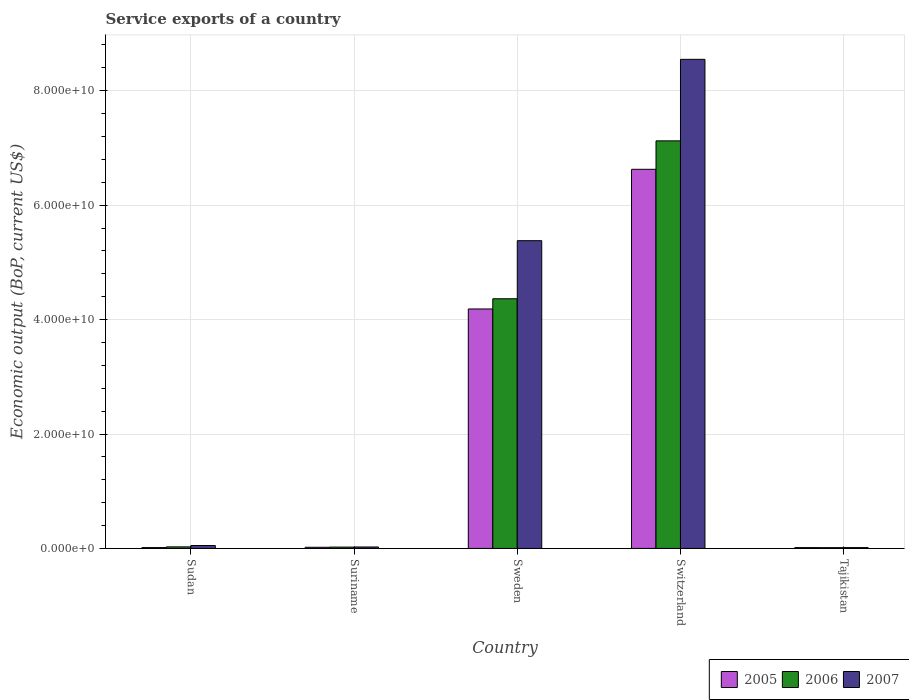How many groups of bars are there?
Offer a terse response. 5. How many bars are there on the 4th tick from the left?
Provide a short and direct response. 3. What is the label of the 2nd group of bars from the left?
Offer a terse response. Suriname. In how many cases, is the number of bars for a given country not equal to the number of legend labels?
Make the answer very short. 0. What is the service exports in 2007 in Switzerland?
Your answer should be compact. 8.55e+1. Across all countries, what is the maximum service exports in 2005?
Your answer should be compact. 6.63e+1. Across all countries, what is the minimum service exports in 2005?
Offer a very short reply. 1.46e+08. In which country was the service exports in 2005 maximum?
Make the answer very short. Switzerland. In which country was the service exports in 2007 minimum?
Ensure brevity in your answer.  Tajikistan. What is the total service exports in 2005 in the graph?
Make the answer very short. 1.09e+11. What is the difference between the service exports in 2007 in Sudan and that in Suriname?
Offer a very short reply. 2.57e+08. What is the difference between the service exports in 2006 in Switzerland and the service exports in 2007 in Tajikistan?
Make the answer very short. 7.11e+1. What is the average service exports in 2005 per country?
Your answer should be compact. 2.17e+1. What is the difference between the service exports of/in 2007 and service exports of/in 2005 in Sudan?
Give a very brief answer. 3.63e+08. In how many countries, is the service exports in 2005 greater than 8000000000 US$?
Your answer should be very brief. 2. What is the ratio of the service exports in 2005 in Suriname to that in Tajikistan?
Ensure brevity in your answer.  1.39. Is the difference between the service exports in 2007 in Sudan and Sweden greater than the difference between the service exports in 2005 in Sudan and Sweden?
Your answer should be compact. No. What is the difference between the highest and the second highest service exports in 2006?
Provide a succinct answer. 7.10e+1. What is the difference between the highest and the lowest service exports in 2005?
Keep it short and to the point. 6.61e+1. Is the sum of the service exports in 2006 in Suriname and Tajikistan greater than the maximum service exports in 2007 across all countries?
Keep it short and to the point. No. What does the 1st bar from the left in Switzerland represents?
Make the answer very short. 2005. What does the 3rd bar from the right in Sweden represents?
Ensure brevity in your answer.  2005. Is it the case that in every country, the sum of the service exports in 2006 and service exports in 2007 is greater than the service exports in 2005?
Give a very brief answer. Yes. Are the values on the major ticks of Y-axis written in scientific E-notation?
Ensure brevity in your answer.  Yes. Does the graph contain any zero values?
Make the answer very short. No. Does the graph contain grids?
Keep it short and to the point. Yes. Where does the legend appear in the graph?
Ensure brevity in your answer.  Bottom right. What is the title of the graph?
Make the answer very short. Service exports of a country. What is the label or title of the X-axis?
Provide a succinct answer. Country. What is the label or title of the Y-axis?
Give a very brief answer. Economic output (BoP, current US$). What is the Economic output (BoP, current US$) of 2005 in Sudan?
Your response must be concise. 1.47e+08. What is the Economic output (BoP, current US$) of 2006 in Sudan?
Offer a terse response. 2.74e+08. What is the Economic output (BoP, current US$) of 2007 in Sudan?
Offer a terse response. 5.10e+08. What is the Economic output (BoP, current US$) of 2005 in Suriname?
Keep it short and to the point. 2.04e+08. What is the Economic output (BoP, current US$) of 2006 in Suriname?
Offer a very short reply. 2.37e+08. What is the Economic output (BoP, current US$) of 2007 in Suriname?
Give a very brief answer. 2.53e+08. What is the Economic output (BoP, current US$) of 2005 in Sweden?
Your answer should be compact. 4.19e+1. What is the Economic output (BoP, current US$) in 2006 in Sweden?
Your answer should be very brief. 4.36e+1. What is the Economic output (BoP, current US$) of 2007 in Sweden?
Your answer should be very brief. 5.38e+1. What is the Economic output (BoP, current US$) of 2005 in Switzerland?
Make the answer very short. 6.63e+1. What is the Economic output (BoP, current US$) of 2006 in Switzerland?
Your answer should be compact. 7.12e+1. What is the Economic output (BoP, current US$) of 2007 in Switzerland?
Make the answer very short. 8.55e+1. What is the Economic output (BoP, current US$) in 2005 in Tajikistan?
Your answer should be very brief. 1.46e+08. What is the Economic output (BoP, current US$) in 2006 in Tajikistan?
Offer a very short reply. 1.34e+08. What is the Economic output (BoP, current US$) of 2007 in Tajikistan?
Your response must be concise. 1.49e+08. Across all countries, what is the maximum Economic output (BoP, current US$) of 2005?
Provide a succinct answer. 6.63e+1. Across all countries, what is the maximum Economic output (BoP, current US$) in 2006?
Give a very brief answer. 7.12e+1. Across all countries, what is the maximum Economic output (BoP, current US$) of 2007?
Your answer should be very brief. 8.55e+1. Across all countries, what is the minimum Economic output (BoP, current US$) of 2005?
Offer a very short reply. 1.46e+08. Across all countries, what is the minimum Economic output (BoP, current US$) in 2006?
Offer a very short reply. 1.34e+08. Across all countries, what is the minimum Economic output (BoP, current US$) in 2007?
Your answer should be compact. 1.49e+08. What is the total Economic output (BoP, current US$) of 2005 in the graph?
Ensure brevity in your answer.  1.09e+11. What is the total Economic output (BoP, current US$) in 2006 in the graph?
Provide a succinct answer. 1.16e+11. What is the total Economic output (BoP, current US$) in 2007 in the graph?
Your answer should be compact. 1.40e+11. What is the difference between the Economic output (BoP, current US$) in 2005 in Sudan and that in Suriname?
Your answer should be very brief. -5.71e+07. What is the difference between the Economic output (BoP, current US$) of 2006 in Sudan and that in Suriname?
Your answer should be compact. 3.73e+07. What is the difference between the Economic output (BoP, current US$) of 2007 in Sudan and that in Suriname?
Your response must be concise. 2.57e+08. What is the difference between the Economic output (BoP, current US$) of 2005 in Sudan and that in Sweden?
Offer a very short reply. -4.17e+1. What is the difference between the Economic output (BoP, current US$) in 2006 in Sudan and that in Sweden?
Your answer should be very brief. -4.34e+1. What is the difference between the Economic output (BoP, current US$) in 2007 in Sudan and that in Sweden?
Your answer should be very brief. -5.33e+1. What is the difference between the Economic output (BoP, current US$) of 2005 in Sudan and that in Switzerland?
Your answer should be compact. -6.61e+1. What is the difference between the Economic output (BoP, current US$) of 2006 in Sudan and that in Switzerland?
Make the answer very short. -7.10e+1. What is the difference between the Economic output (BoP, current US$) in 2007 in Sudan and that in Switzerland?
Provide a succinct answer. -8.50e+1. What is the difference between the Economic output (BoP, current US$) in 2005 in Sudan and that in Tajikistan?
Provide a succinct answer. 6.82e+05. What is the difference between the Economic output (BoP, current US$) of 2006 in Sudan and that in Tajikistan?
Keep it short and to the point. 1.40e+08. What is the difference between the Economic output (BoP, current US$) of 2007 in Sudan and that in Tajikistan?
Your answer should be very brief. 3.62e+08. What is the difference between the Economic output (BoP, current US$) of 2005 in Suriname and that in Sweden?
Your answer should be compact. -4.17e+1. What is the difference between the Economic output (BoP, current US$) of 2006 in Suriname and that in Sweden?
Your answer should be compact. -4.34e+1. What is the difference between the Economic output (BoP, current US$) in 2007 in Suriname and that in Sweden?
Offer a very short reply. -5.35e+1. What is the difference between the Economic output (BoP, current US$) in 2005 in Suriname and that in Switzerland?
Give a very brief answer. -6.61e+1. What is the difference between the Economic output (BoP, current US$) in 2006 in Suriname and that in Switzerland?
Offer a terse response. -7.10e+1. What is the difference between the Economic output (BoP, current US$) of 2007 in Suriname and that in Switzerland?
Ensure brevity in your answer.  -8.52e+1. What is the difference between the Economic output (BoP, current US$) of 2005 in Suriname and that in Tajikistan?
Provide a succinct answer. 5.78e+07. What is the difference between the Economic output (BoP, current US$) in 2006 in Suriname and that in Tajikistan?
Make the answer very short. 1.02e+08. What is the difference between the Economic output (BoP, current US$) of 2007 in Suriname and that in Tajikistan?
Ensure brevity in your answer.  1.05e+08. What is the difference between the Economic output (BoP, current US$) of 2005 in Sweden and that in Switzerland?
Offer a very short reply. -2.44e+1. What is the difference between the Economic output (BoP, current US$) in 2006 in Sweden and that in Switzerland?
Your answer should be very brief. -2.76e+1. What is the difference between the Economic output (BoP, current US$) of 2007 in Sweden and that in Switzerland?
Your response must be concise. -3.17e+1. What is the difference between the Economic output (BoP, current US$) in 2005 in Sweden and that in Tajikistan?
Offer a terse response. 4.17e+1. What is the difference between the Economic output (BoP, current US$) of 2006 in Sweden and that in Tajikistan?
Your answer should be compact. 4.35e+1. What is the difference between the Economic output (BoP, current US$) of 2007 in Sweden and that in Tajikistan?
Make the answer very short. 5.36e+1. What is the difference between the Economic output (BoP, current US$) in 2005 in Switzerland and that in Tajikistan?
Provide a succinct answer. 6.61e+1. What is the difference between the Economic output (BoP, current US$) in 2006 in Switzerland and that in Tajikistan?
Offer a terse response. 7.11e+1. What is the difference between the Economic output (BoP, current US$) in 2007 in Switzerland and that in Tajikistan?
Offer a very short reply. 8.53e+1. What is the difference between the Economic output (BoP, current US$) of 2005 in Sudan and the Economic output (BoP, current US$) of 2006 in Suriname?
Offer a very short reply. -8.96e+07. What is the difference between the Economic output (BoP, current US$) in 2005 in Sudan and the Economic output (BoP, current US$) in 2007 in Suriname?
Give a very brief answer. -1.06e+08. What is the difference between the Economic output (BoP, current US$) of 2006 in Sudan and the Economic output (BoP, current US$) of 2007 in Suriname?
Your response must be concise. 2.05e+07. What is the difference between the Economic output (BoP, current US$) in 2005 in Sudan and the Economic output (BoP, current US$) in 2006 in Sweden?
Keep it short and to the point. -4.35e+1. What is the difference between the Economic output (BoP, current US$) in 2005 in Sudan and the Economic output (BoP, current US$) in 2007 in Sweden?
Ensure brevity in your answer.  -5.36e+1. What is the difference between the Economic output (BoP, current US$) of 2006 in Sudan and the Economic output (BoP, current US$) of 2007 in Sweden?
Keep it short and to the point. -5.35e+1. What is the difference between the Economic output (BoP, current US$) of 2005 in Sudan and the Economic output (BoP, current US$) of 2006 in Switzerland?
Keep it short and to the point. -7.11e+1. What is the difference between the Economic output (BoP, current US$) of 2005 in Sudan and the Economic output (BoP, current US$) of 2007 in Switzerland?
Offer a very short reply. -8.53e+1. What is the difference between the Economic output (BoP, current US$) of 2006 in Sudan and the Economic output (BoP, current US$) of 2007 in Switzerland?
Ensure brevity in your answer.  -8.52e+1. What is the difference between the Economic output (BoP, current US$) in 2005 in Sudan and the Economic output (BoP, current US$) in 2006 in Tajikistan?
Provide a succinct answer. 1.28e+07. What is the difference between the Economic output (BoP, current US$) of 2005 in Sudan and the Economic output (BoP, current US$) of 2007 in Tajikistan?
Your answer should be very brief. -1.67e+06. What is the difference between the Economic output (BoP, current US$) of 2006 in Sudan and the Economic output (BoP, current US$) of 2007 in Tajikistan?
Provide a short and direct response. 1.25e+08. What is the difference between the Economic output (BoP, current US$) of 2005 in Suriname and the Economic output (BoP, current US$) of 2006 in Sweden?
Give a very brief answer. -4.34e+1. What is the difference between the Economic output (BoP, current US$) in 2005 in Suriname and the Economic output (BoP, current US$) in 2007 in Sweden?
Offer a terse response. -5.36e+1. What is the difference between the Economic output (BoP, current US$) in 2006 in Suriname and the Economic output (BoP, current US$) in 2007 in Sweden?
Provide a succinct answer. -5.36e+1. What is the difference between the Economic output (BoP, current US$) of 2005 in Suriname and the Economic output (BoP, current US$) of 2006 in Switzerland?
Make the answer very short. -7.10e+1. What is the difference between the Economic output (BoP, current US$) of 2005 in Suriname and the Economic output (BoP, current US$) of 2007 in Switzerland?
Your answer should be compact. -8.53e+1. What is the difference between the Economic output (BoP, current US$) of 2006 in Suriname and the Economic output (BoP, current US$) of 2007 in Switzerland?
Give a very brief answer. -8.53e+1. What is the difference between the Economic output (BoP, current US$) of 2005 in Suriname and the Economic output (BoP, current US$) of 2006 in Tajikistan?
Ensure brevity in your answer.  6.99e+07. What is the difference between the Economic output (BoP, current US$) of 2005 in Suriname and the Economic output (BoP, current US$) of 2007 in Tajikistan?
Offer a very short reply. 5.54e+07. What is the difference between the Economic output (BoP, current US$) of 2006 in Suriname and the Economic output (BoP, current US$) of 2007 in Tajikistan?
Offer a very short reply. 8.79e+07. What is the difference between the Economic output (BoP, current US$) of 2005 in Sweden and the Economic output (BoP, current US$) of 2006 in Switzerland?
Provide a succinct answer. -2.94e+1. What is the difference between the Economic output (BoP, current US$) in 2005 in Sweden and the Economic output (BoP, current US$) in 2007 in Switzerland?
Your answer should be very brief. -4.36e+1. What is the difference between the Economic output (BoP, current US$) in 2006 in Sweden and the Economic output (BoP, current US$) in 2007 in Switzerland?
Give a very brief answer. -4.18e+1. What is the difference between the Economic output (BoP, current US$) of 2005 in Sweden and the Economic output (BoP, current US$) of 2006 in Tajikistan?
Your answer should be very brief. 4.17e+1. What is the difference between the Economic output (BoP, current US$) of 2005 in Sweden and the Economic output (BoP, current US$) of 2007 in Tajikistan?
Offer a terse response. 4.17e+1. What is the difference between the Economic output (BoP, current US$) of 2006 in Sweden and the Economic output (BoP, current US$) of 2007 in Tajikistan?
Your answer should be very brief. 4.35e+1. What is the difference between the Economic output (BoP, current US$) of 2005 in Switzerland and the Economic output (BoP, current US$) of 2006 in Tajikistan?
Offer a very short reply. 6.61e+1. What is the difference between the Economic output (BoP, current US$) in 2005 in Switzerland and the Economic output (BoP, current US$) in 2007 in Tajikistan?
Your response must be concise. 6.61e+1. What is the difference between the Economic output (BoP, current US$) of 2006 in Switzerland and the Economic output (BoP, current US$) of 2007 in Tajikistan?
Your answer should be very brief. 7.11e+1. What is the average Economic output (BoP, current US$) in 2005 per country?
Make the answer very short. 2.17e+1. What is the average Economic output (BoP, current US$) in 2006 per country?
Give a very brief answer. 2.31e+1. What is the average Economic output (BoP, current US$) of 2007 per country?
Your answer should be compact. 2.80e+1. What is the difference between the Economic output (BoP, current US$) in 2005 and Economic output (BoP, current US$) in 2006 in Sudan?
Provide a succinct answer. -1.27e+08. What is the difference between the Economic output (BoP, current US$) of 2005 and Economic output (BoP, current US$) of 2007 in Sudan?
Give a very brief answer. -3.63e+08. What is the difference between the Economic output (BoP, current US$) in 2006 and Economic output (BoP, current US$) in 2007 in Sudan?
Make the answer very short. -2.36e+08. What is the difference between the Economic output (BoP, current US$) in 2005 and Economic output (BoP, current US$) in 2006 in Suriname?
Provide a succinct answer. -3.25e+07. What is the difference between the Economic output (BoP, current US$) of 2005 and Economic output (BoP, current US$) of 2007 in Suriname?
Offer a terse response. -4.93e+07. What is the difference between the Economic output (BoP, current US$) of 2006 and Economic output (BoP, current US$) of 2007 in Suriname?
Provide a succinct answer. -1.68e+07. What is the difference between the Economic output (BoP, current US$) in 2005 and Economic output (BoP, current US$) in 2006 in Sweden?
Offer a very short reply. -1.78e+09. What is the difference between the Economic output (BoP, current US$) of 2005 and Economic output (BoP, current US$) of 2007 in Sweden?
Provide a short and direct response. -1.19e+1. What is the difference between the Economic output (BoP, current US$) of 2006 and Economic output (BoP, current US$) of 2007 in Sweden?
Provide a short and direct response. -1.02e+1. What is the difference between the Economic output (BoP, current US$) of 2005 and Economic output (BoP, current US$) of 2006 in Switzerland?
Offer a very short reply. -4.97e+09. What is the difference between the Economic output (BoP, current US$) in 2005 and Economic output (BoP, current US$) in 2007 in Switzerland?
Offer a very short reply. -1.92e+1. What is the difference between the Economic output (BoP, current US$) of 2006 and Economic output (BoP, current US$) of 2007 in Switzerland?
Your answer should be compact. -1.42e+1. What is the difference between the Economic output (BoP, current US$) of 2005 and Economic output (BoP, current US$) of 2006 in Tajikistan?
Keep it short and to the point. 1.21e+07. What is the difference between the Economic output (BoP, current US$) in 2005 and Economic output (BoP, current US$) in 2007 in Tajikistan?
Provide a succinct answer. -2.35e+06. What is the difference between the Economic output (BoP, current US$) in 2006 and Economic output (BoP, current US$) in 2007 in Tajikistan?
Ensure brevity in your answer.  -1.45e+07. What is the ratio of the Economic output (BoP, current US$) of 2005 in Sudan to that in Suriname?
Your answer should be very brief. 0.72. What is the ratio of the Economic output (BoP, current US$) of 2006 in Sudan to that in Suriname?
Offer a very short reply. 1.16. What is the ratio of the Economic output (BoP, current US$) of 2007 in Sudan to that in Suriname?
Offer a terse response. 2.01. What is the ratio of the Economic output (BoP, current US$) of 2005 in Sudan to that in Sweden?
Keep it short and to the point. 0. What is the ratio of the Economic output (BoP, current US$) in 2006 in Sudan to that in Sweden?
Make the answer very short. 0.01. What is the ratio of the Economic output (BoP, current US$) in 2007 in Sudan to that in Sweden?
Your response must be concise. 0.01. What is the ratio of the Economic output (BoP, current US$) in 2005 in Sudan to that in Switzerland?
Your answer should be very brief. 0. What is the ratio of the Economic output (BoP, current US$) of 2006 in Sudan to that in Switzerland?
Ensure brevity in your answer.  0. What is the ratio of the Economic output (BoP, current US$) of 2007 in Sudan to that in Switzerland?
Your answer should be compact. 0.01. What is the ratio of the Economic output (BoP, current US$) in 2005 in Sudan to that in Tajikistan?
Your answer should be compact. 1. What is the ratio of the Economic output (BoP, current US$) of 2006 in Sudan to that in Tajikistan?
Your response must be concise. 2.04. What is the ratio of the Economic output (BoP, current US$) of 2007 in Sudan to that in Tajikistan?
Provide a short and direct response. 3.43. What is the ratio of the Economic output (BoP, current US$) in 2005 in Suriname to that in Sweden?
Provide a succinct answer. 0. What is the ratio of the Economic output (BoP, current US$) in 2006 in Suriname to that in Sweden?
Make the answer very short. 0.01. What is the ratio of the Economic output (BoP, current US$) of 2007 in Suriname to that in Sweden?
Keep it short and to the point. 0. What is the ratio of the Economic output (BoP, current US$) of 2005 in Suriname to that in Switzerland?
Ensure brevity in your answer.  0. What is the ratio of the Economic output (BoP, current US$) of 2006 in Suriname to that in Switzerland?
Your answer should be compact. 0. What is the ratio of the Economic output (BoP, current US$) in 2007 in Suriname to that in Switzerland?
Keep it short and to the point. 0. What is the ratio of the Economic output (BoP, current US$) of 2005 in Suriname to that in Tajikistan?
Offer a very short reply. 1.39. What is the ratio of the Economic output (BoP, current US$) in 2006 in Suriname to that in Tajikistan?
Provide a succinct answer. 1.76. What is the ratio of the Economic output (BoP, current US$) of 2007 in Suriname to that in Tajikistan?
Make the answer very short. 1.7. What is the ratio of the Economic output (BoP, current US$) in 2005 in Sweden to that in Switzerland?
Your answer should be very brief. 0.63. What is the ratio of the Economic output (BoP, current US$) of 2006 in Sweden to that in Switzerland?
Give a very brief answer. 0.61. What is the ratio of the Economic output (BoP, current US$) in 2007 in Sweden to that in Switzerland?
Provide a succinct answer. 0.63. What is the ratio of the Economic output (BoP, current US$) in 2005 in Sweden to that in Tajikistan?
Offer a very short reply. 286.03. What is the ratio of the Economic output (BoP, current US$) in 2006 in Sweden to that in Tajikistan?
Make the answer very short. 325.17. What is the ratio of the Economic output (BoP, current US$) in 2007 in Sweden to that in Tajikistan?
Your response must be concise. 361.78. What is the ratio of the Economic output (BoP, current US$) of 2005 in Switzerland to that in Tajikistan?
Your answer should be very brief. 452.84. What is the ratio of the Economic output (BoP, current US$) of 2006 in Switzerland to that in Tajikistan?
Provide a short and direct response. 530.8. What is the ratio of the Economic output (BoP, current US$) of 2007 in Switzerland to that in Tajikistan?
Offer a very short reply. 574.95. What is the difference between the highest and the second highest Economic output (BoP, current US$) of 2005?
Offer a terse response. 2.44e+1. What is the difference between the highest and the second highest Economic output (BoP, current US$) in 2006?
Ensure brevity in your answer.  2.76e+1. What is the difference between the highest and the second highest Economic output (BoP, current US$) of 2007?
Provide a short and direct response. 3.17e+1. What is the difference between the highest and the lowest Economic output (BoP, current US$) in 2005?
Keep it short and to the point. 6.61e+1. What is the difference between the highest and the lowest Economic output (BoP, current US$) of 2006?
Offer a very short reply. 7.11e+1. What is the difference between the highest and the lowest Economic output (BoP, current US$) of 2007?
Offer a terse response. 8.53e+1. 